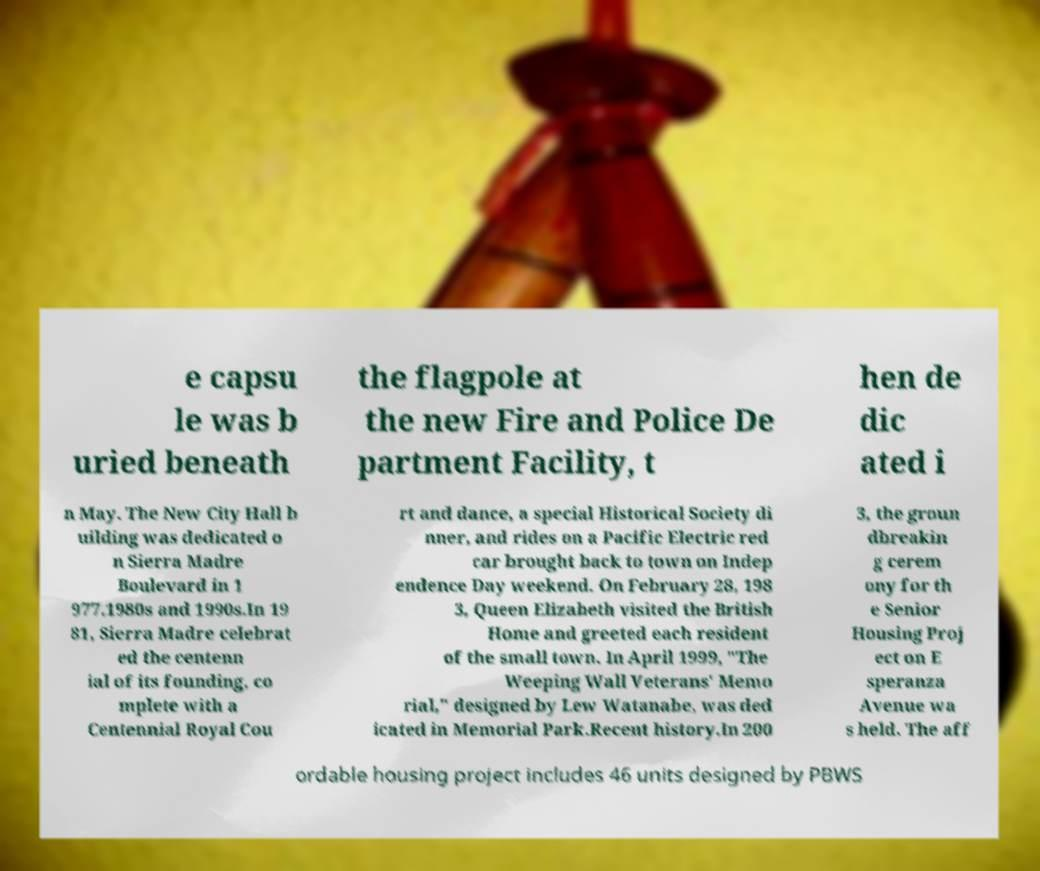Please read and relay the text visible in this image. What does it say? e capsu le was b uried beneath the flagpole at the new Fire and Police De partment Facility, t hen de dic ated i n May. The New City Hall b uilding was dedicated o n Sierra Madre Boulevard in 1 977.1980s and 1990s.In 19 81, Sierra Madre celebrat ed the centenn ial of its founding, co mplete with a Centennial Royal Cou rt and dance, a special Historical Society di nner, and rides on a Pacific Electric red car brought back to town on Indep endence Day weekend. On February 28, 198 3, Queen Elizabeth visited the British Home and greeted each resident of the small town. In April 1999, "The Weeping Wall Veterans' Memo rial," designed by Lew Watanabe, was ded icated in Memorial Park.Recent history.In 200 3, the groun dbreakin g cerem ony for th e Senior Housing Proj ect on E speranza Avenue wa s held. The aff ordable housing project includes 46 units designed by PBWS 